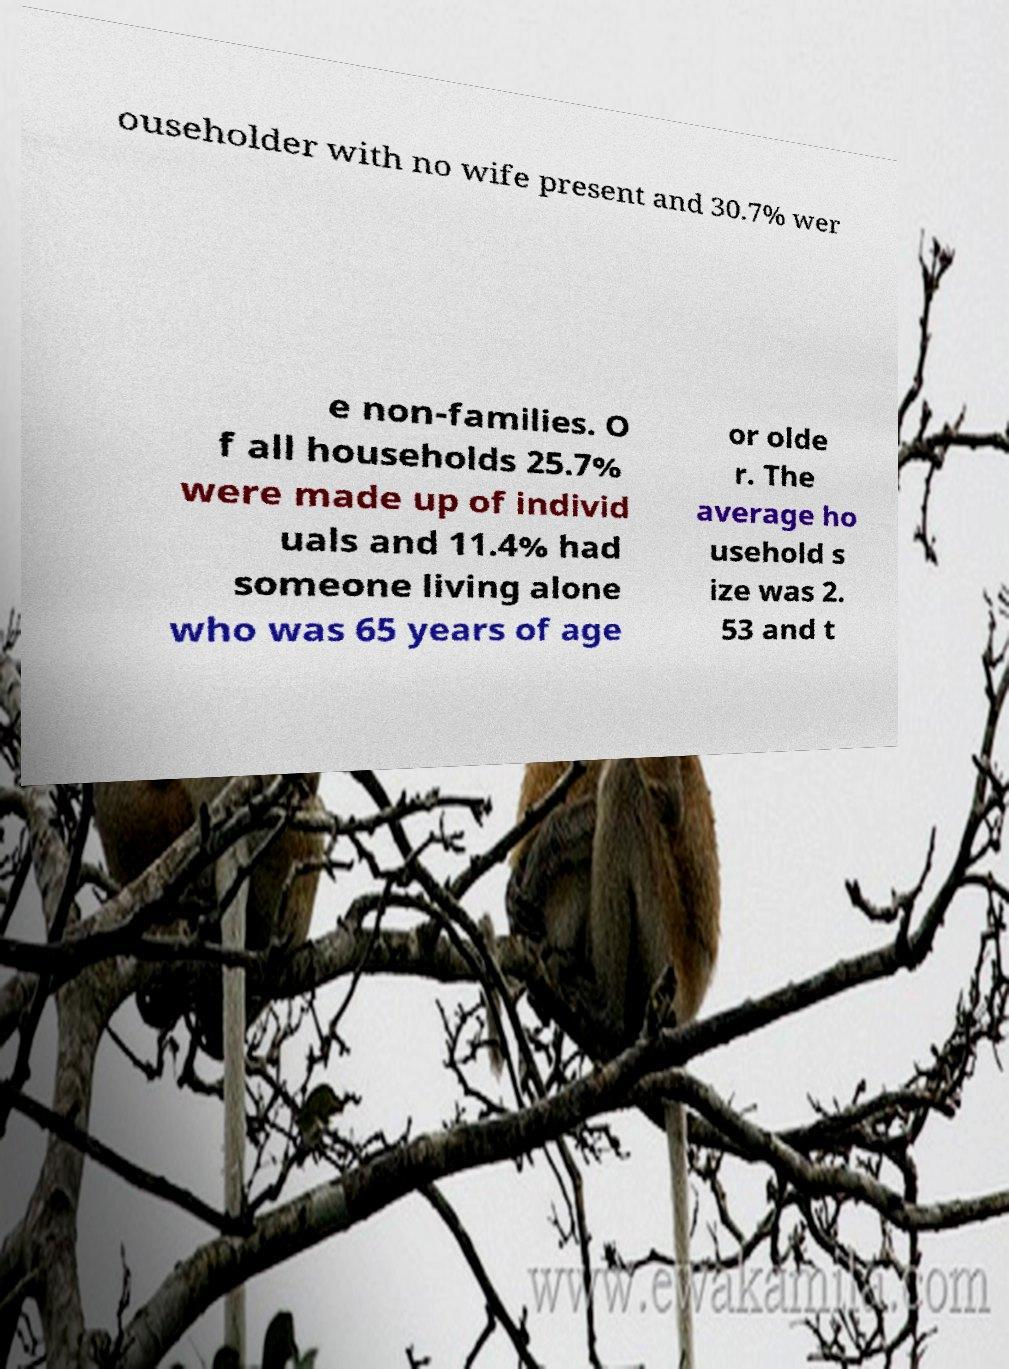There's text embedded in this image that I need extracted. Can you transcribe it verbatim? ouseholder with no wife present and 30.7% wer e non-families. O f all households 25.7% were made up of individ uals and 11.4% had someone living alone who was 65 years of age or olde r. The average ho usehold s ize was 2. 53 and t 